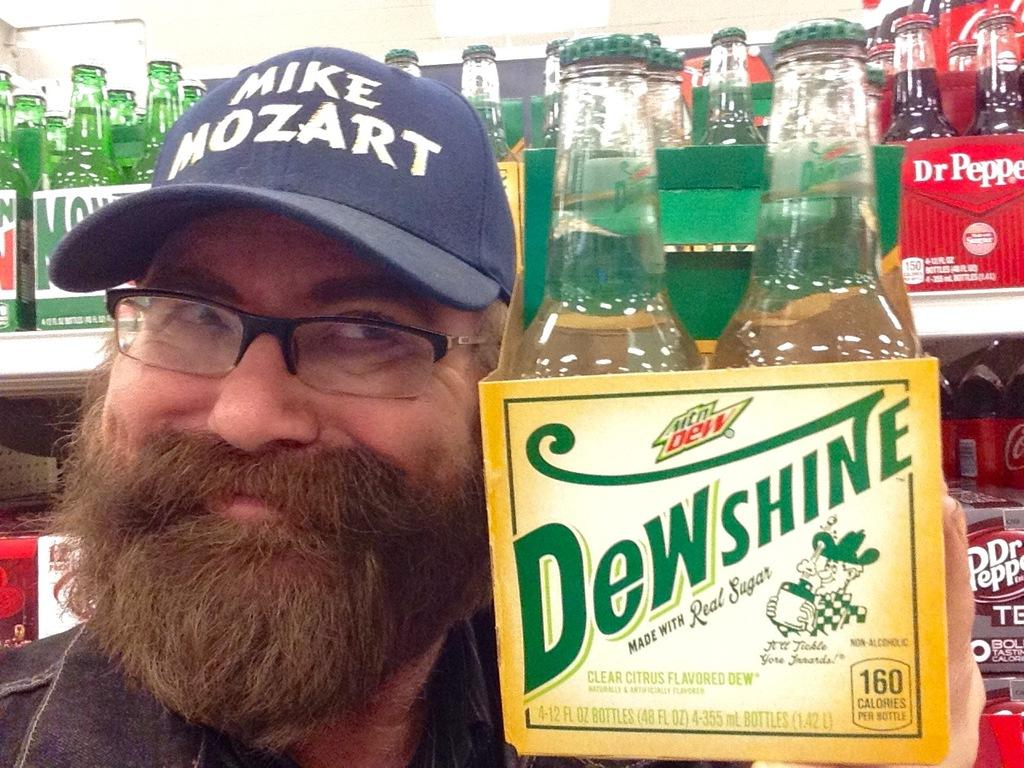Who is present in the image? There is a man in the image. What is the man holding in the image? The man is holding a bottle. What can be seen in the background of the image? There are bottles on a rack in the background of the image. How much knowledge is the man gaining from the meal in the image? There is no meal present in the image, and therefore no knowledge can be gained from it. 